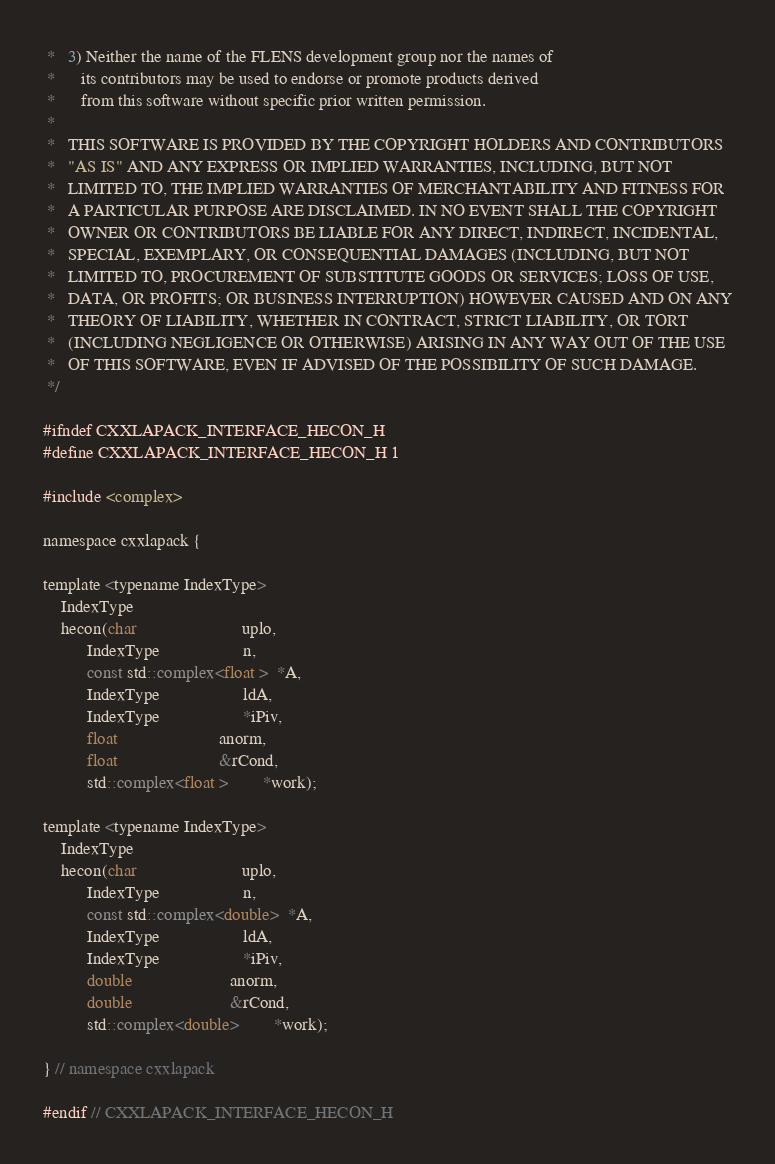Convert code to text. <code><loc_0><loc_0><loc_500><loc_500><_C_> *   3) Neither the name of the FLENS development group nor the names of
 *      its contributors may be used to endorse or promote products derived
 *      from this software without specific prior written permission.
 *
 *   THIS SOFTWARE IS PROVIDED BY THE COPYRIGHT HOLDERS AND CONTRIBUTORS
 *   "AS IS" AND ANY EXPRESS OR IMPLIED WARRANTIES, INCLUDING, BUT NOT
 *   LIMITED TO, THE IMPLIED WARRANTIES OF MERCHANTABILITY AND FITNESS FOR
 *   A PARTICULAR PURPOSE ARE DISCLAIMED. IN NO EVENT SHALL THE COPYRIGHT
 *   OWNER OR CONTRIBUTORS BE LIABLE FOR ANY DIRECT, INDIRECT, INCIDENTAL,
 *   SPECIAL, EXEMPLARY, OR CONSEQUENTIAL DAMAGES (INCLUDING, BUT NOT
 *   LIMITED TO, PROCUREMENT OF SUBSTITUTE GOODS OR SERVICES; LOSS OF USE,
 *   DATA, OR PROFITS; OR BUSINESS INTERRUPTION) HOWEVER CAUSED AND ON ANY
 *   THEORY OF LIABILITY, WHETHER IN CONTRACT, STRICT LIABILITY, OR TORT
 *   (INCLUDING NEGLIGENCE OR OTHERWISE) ARISING IN ANY WAY OUT OF THE USE
 *   OF THIS SOFTWARE, EVEN IF ADVISED OF THE POSSIBILITY OF SUCH DAMAGE.
 */

#ifndef CXXLAPACK_INTERFACE_HECON_H
#define CXXLAPACK_INTERFACE_HECON_H 1

#include <complex>

namespace cxxlapack {

template <typename IndexType>
    IndexType
    hecon(char                        uplo,
          IndexType                   n,
          const std::complex<float >  *A,
          IndexType                   ldA,
          IndexType                   *iPiv,
          float                       anorm,
          float                       &rCond,
          std::complex<float >        *work);

template <typename IndexType>
    IndexType
    hecon(char                        uplo,
          IndexType                   n,
          const std::complex<double>  *A,
          IndexType                   ldA,
          IndexType                   *iPiv,
          double                      anorm,
          double                      &rCond,
          std::complex<double>        *work);

} // namespace cxxlapack

#endif // CXXLAPACK_INTERFACE_HECON_H
</code> 